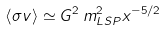<formula> <loc_0><loc_0><loc_500><loc_500>\left < \sigma v \right > \simeq G ^ { 2 } \, m _ { L S P } ^ { 2 } x ^ { - 5 / 2 }</formula> 